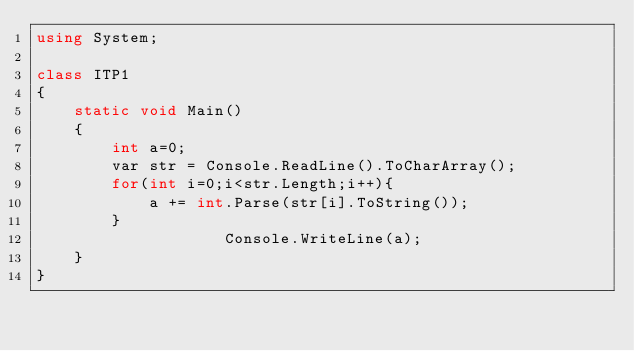Convert code to text. <code><loc_0><loc_0><loc_500><loc_500><_C#_>using System;

class ITP1
{
    static void Main()
    {
        int a=0;
        var str = Console.ReadLine().ToCharArray();
        for(int i=0;i<str.Length;i++){
            a += int.Parse(str[i].ToString());
        }
                    Console.WriteLine(a);
    }
}</code> 